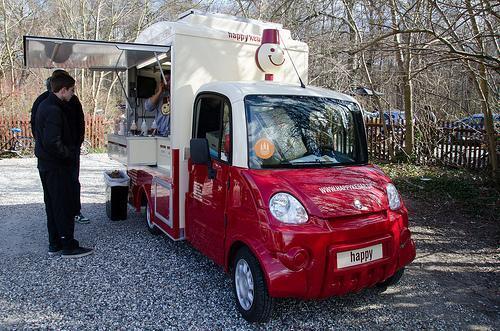How many trucks are there?
Give a very brief answer. 1. 